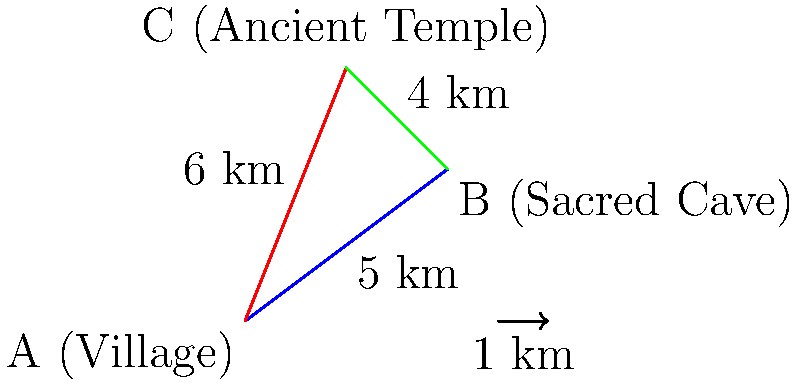On an island where you're conducting anthropological fieldwork, there are three significant locations: the main village (A), a sacred cave (B), and an ancient temple (C). The distances between these locations are as follows:
- Village to Sacred Cave: 5 km
- Village to Ancient Temple: 6 km
- Sacred Cave to Ancient Temple: 4 km

You need to travel from the village to the ancient temple. What is the shortest possible distance for this journey? To solve this problem, we need to determine whether the direct path from A to C is shorter than the path from A to B to C.

Step 1: Calculate the direct distance from A to C.
This is given as 6 km.

Step 2: Calculate the distance from A to C via B.
Distance A to B = 5 km
Distance B to C = 4 km
Total distance A to B to C = 5 km + 4 km = 9 km

Step 3: Compare the two distances.
Direct path (A to C): 6 km
Indirect path (A to B to C): 9 km

Step 4: Choose the shorter path.
The direct path from A to C (6 km) is shorter than the path through B (9 km).

Therefore, the shortest possible distance for the journey from the village to the ancient temple is 6 km.
Answer: 6 km 